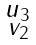<formula> <loc_0><loc_0><loc_500><loc_500>\begin{smallmatrix} u _ { 3 } \\ v _ { 2 } \end{smallmatrix}</formula> 